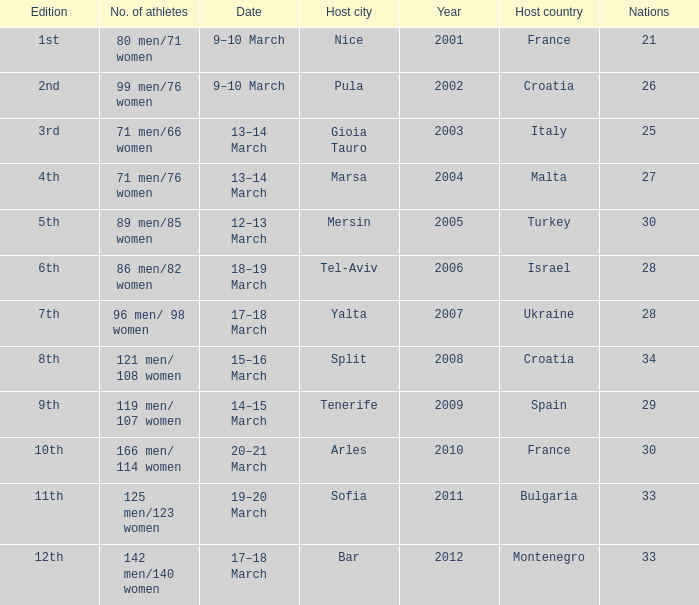What was the host city of the 8th edition in the the host country of Croatia? Split. 